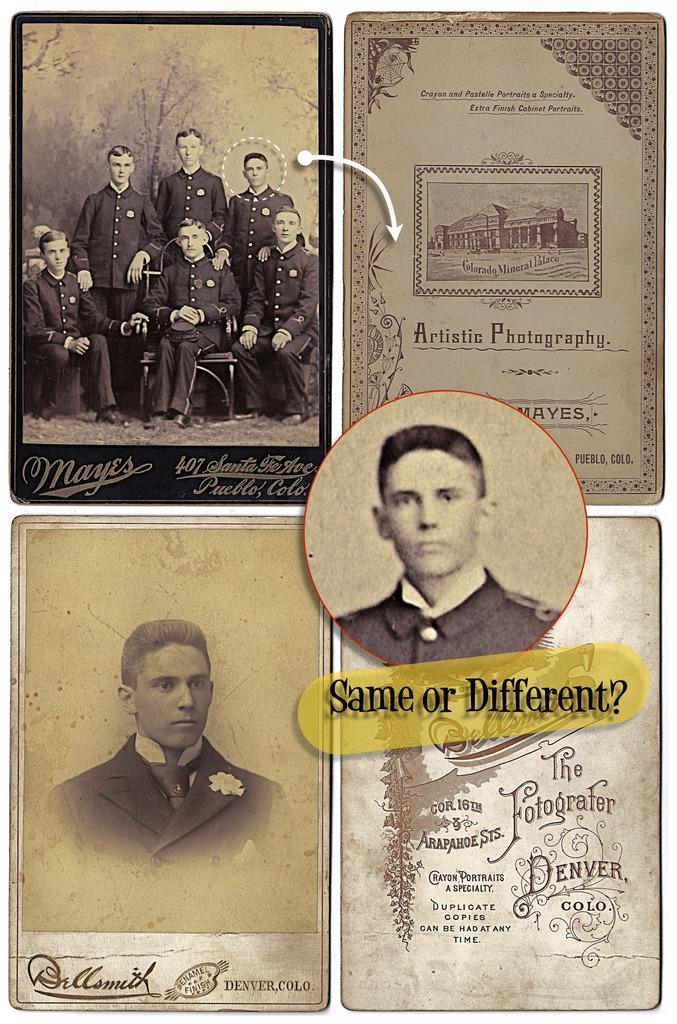How many posters are present in the image? There are four posters in the image. What do the posters have in common? Each poster has a person wearing a black dress. What else can be seen on the right side of the image? There appears to be a certificate on the right side of the image. How many ladybugs are crawling on the posters in the image? There are no ladybugs present in the image. What type of twig is used as a prop in the image? There is no twig present in the image. 